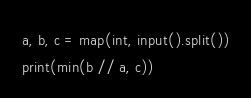<code> <loc_0><loc_0><loc_500><loc_500><_Python_>a, b, c = map(int, input().split())
print(min(b // a, c))</code> 